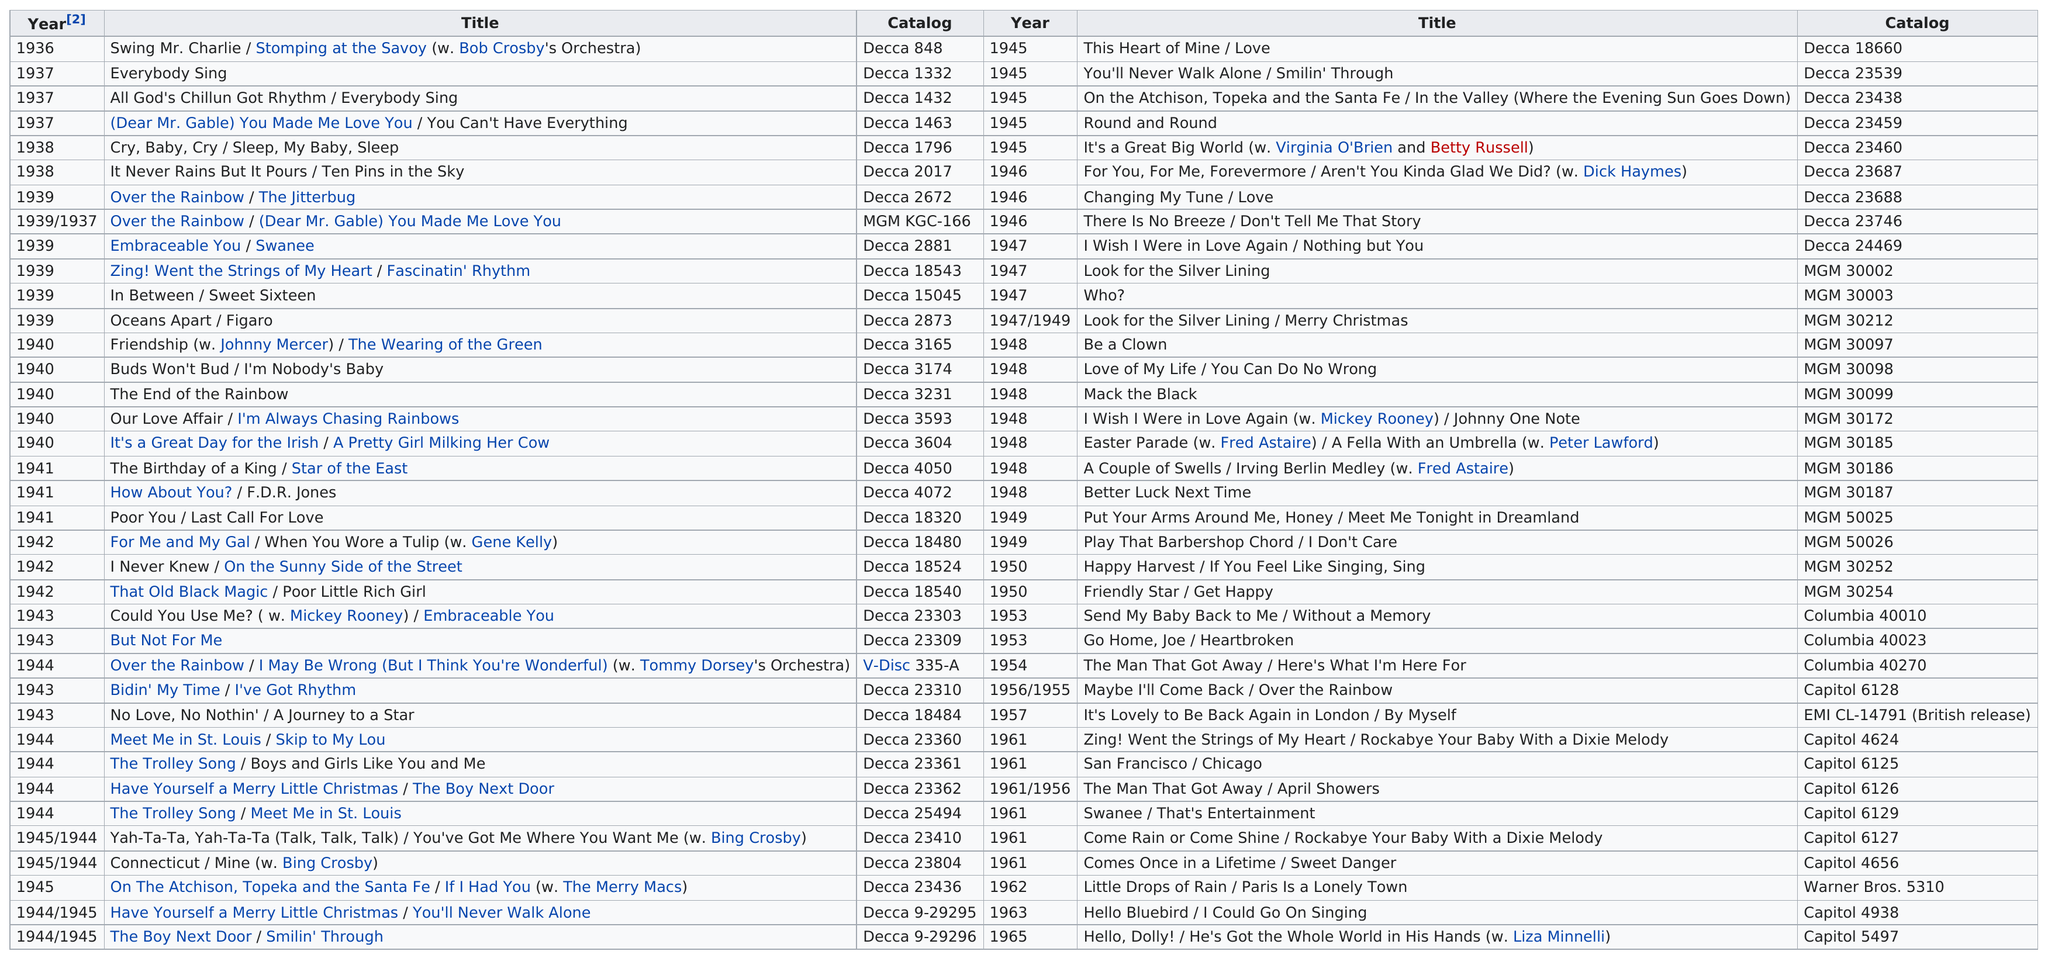Point out several critical features in this image. The last single to be released was 'Hello, Dolly!' / 'He's Got the Whole World in His Hands' with Liza Minnelli. The End of the Rainbow was released sooner than Mack the Black. The first single to be released was "Swing Mr. Charlie" / "Stomping at the Savoy" with Bob Crosby's Orchestra. There were 46 singles released in the 1940s. The Decca catalog number of the single "Everybody Sing" is Decca 1332. 